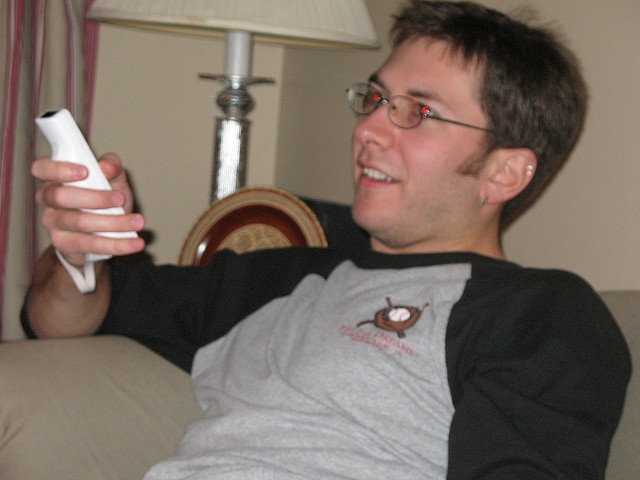Describe the objects in this image and their specific colors. I can see people in gray, black, and darkgray tones, couch in gray and black tones, chair in gray and black tones, and remote in gray, lightgray, and darkgray tones in this image. 